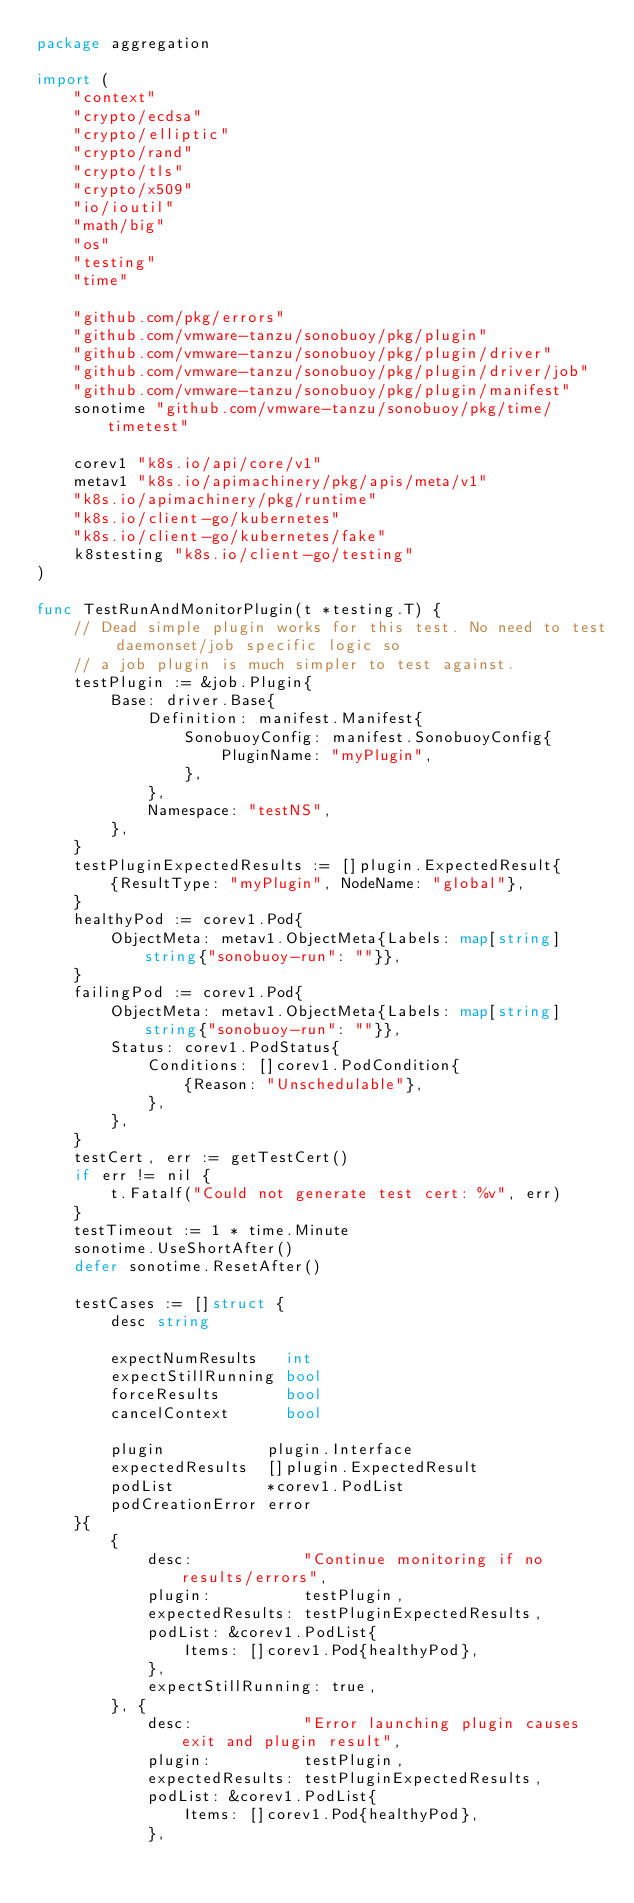Convert code to text. <code><loc_0><loc_0><loc_500><loc_500><_Go_>package aggregation

import (
	"context"
	"crypto/ecdsa"
	"crypto/elliptic"
	"crypto/rand"
	"crypto/tls"
	"crypto/x509"
	"io/ioutil"
	"math/big"
	"os"
	"testing"
	"time"

	"github.com/pkg/errors"
	"github.com/vmware-tanzu/sonobuoy/pkg/plugin"
	"github.com/vmware-tanzu/sonobuoy/pkg/plugin/driver"
	"github.com/vmware-tanzu/sonobuoy/pkg/plugin/driver/job"
	"github.com/vmware-tanzu/sonobuoy/pkg/plugin/manifest"
	sonotime "github.com/vmware-tanzu/sonobuoy/pkg/time/timetest"

	corev1 "k8s.io/api/core/v1"
	metav1 "k8s.io/apimachinery/pkg/apis/meta/v1"
	"k8s.io/apimachinery/pkg/runtime"
	"k8s.io/client-go/kubernetes"
	"k8s.io/client-go/kubernetes/fake"
	k8stesting "k8s.io/client-go/testing"
)

func TestRunAndMonitorPlugin(t *testing.T) {
	// Dead simple plugin works for this test. No need to test daemonset/job specific logic so
	// a job plugin is much simpler to test against.
	testPlugin := &job.Plugin{
		Base: driver.Base{
			Definition: manifest.Manifest{
				SonobuoyConfig: manifest.SonobuoyConfig{
					PluginName: "myPlugin",
				},
			},
			Namespace: "testNS",
		},
	}
	testPluginExpectedResults := []plugin.ExpectedResult{
		{ResultType: "myPlugin", NodeName: "global"},
	}
	healthyPod := corev1.Pod{
		ObjectMeta: metav1.ObjectMeta{Labels: map[string]string{"sonobuoy-run": ""}},
	}
	failingPod := corev1.Pod{
		ObjectMeta: metav1.ObjectMeta{Labels: map[string]string{"sonobuoy-run": ""}},
		Status: corev1.PodStatus{
			Conditions: []corev1.PodCondition{
				{Reason: "Unschedulable"},
			},
		},
	}
	testCert, err := getTestCert()
	if err != nil {
		t.Fatalf("Could not generate test cert: %v", err)
	}
	testTimeout := 1 * time.Minute
	sonotime.UseShortAfter()
	defer sonotime.ResetAfter()

	testCases := []struct {
		desc string

		expectNumResults   int
		expectStillRunning bool
		forceResults       bool
		cancelContext      bool

		plugin           plugin.Interface
		expectedResults  []plugin.ExpectedResult
		podList          *corev1.PodList
		podCreationError error
	}{
		{
			desc:            "Continue monitoring if no results/errors",
			plugin:          testPlugin,
			expectedResults: testPluginExpectedResults,
			podList: &corev1.PodList{
				Items: []corev1.Pod{healthyPod},
			},
			expectStillRunning: true,
		}, {
			desc:            "Error launching plugin causes exit and plugin result",
			plugin:          testPlugin,
			expectedResults: testPluginExpectedResults,
			podList: &corev1.PodList{
				Items: []corev1.Pod{healthyPod},
			},</code> 